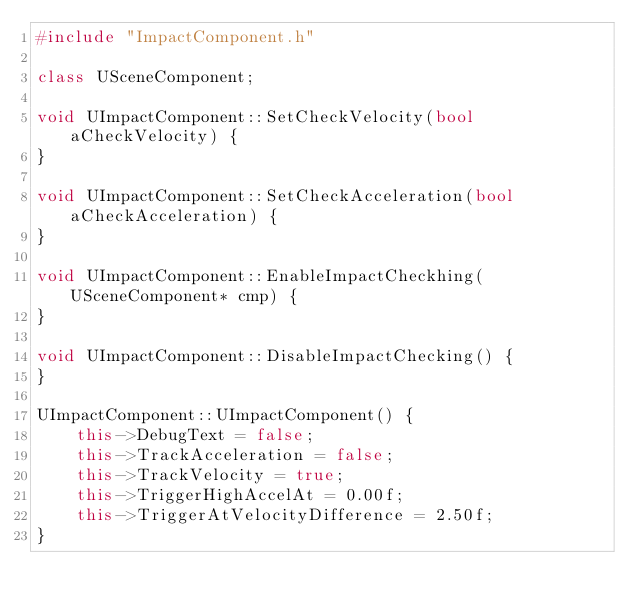<code> <loc_0><loc_0><loc_500><loc_500><_C++_>#include "ImpactComponent.h"

class USceneComponent;

void UImpactComponent::SetCheckVelocity(bool aCheckVelocity) {
}

void UImpactComponent::SetCheckAcceleration(bool aCheckAcceleration) {
}

void UImpactComponent::EnableImpactCheckhing(USceneComponent* cmp) {
}

void UImpactComponent::DisableImpactChecking() {
}

UImpactComponent::UImpactComponent() {
    this->DebugText = false;
    this->TrackAcceleration = false;
    this->TrackVelocity = true;
    this->TriggerHighAccelAt = 0.00f;
    this->TriggerAtVelocityDifference = 2.50f;
}

</code> 